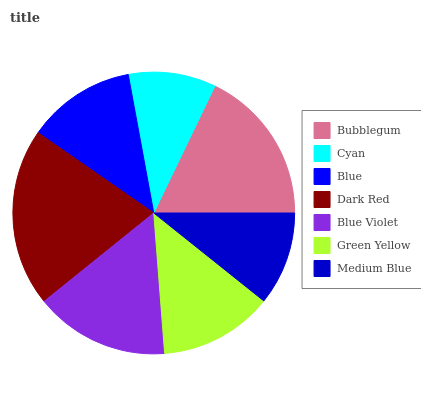Is Cyan the minimum?
Answer yes or no. Yes. Is Dark Red the maximum?
Answer yes or no. Yes. Is Blue the minimum?
Answer yes or no. No. Is Blue the maximum?
Answer yes or no. No. Is Blue greater than Cyan?
Answer yes or no. Yes. Is Cyan less than Blue?
Answer yes or no. Yes. Is Cyan greater than Blue?
Answer yes or no. No. Is Blue less than Cyan?
Answer yes or no. No. Is Green Yellow the high median?
Answer yes or no. Yes. Is Green Yellow the low median?
Answer yes or no. Yes. Is Cyan the high median?
Answer yes or no. No. Is Bubblegum the low median?
Answer yes or no. No. 